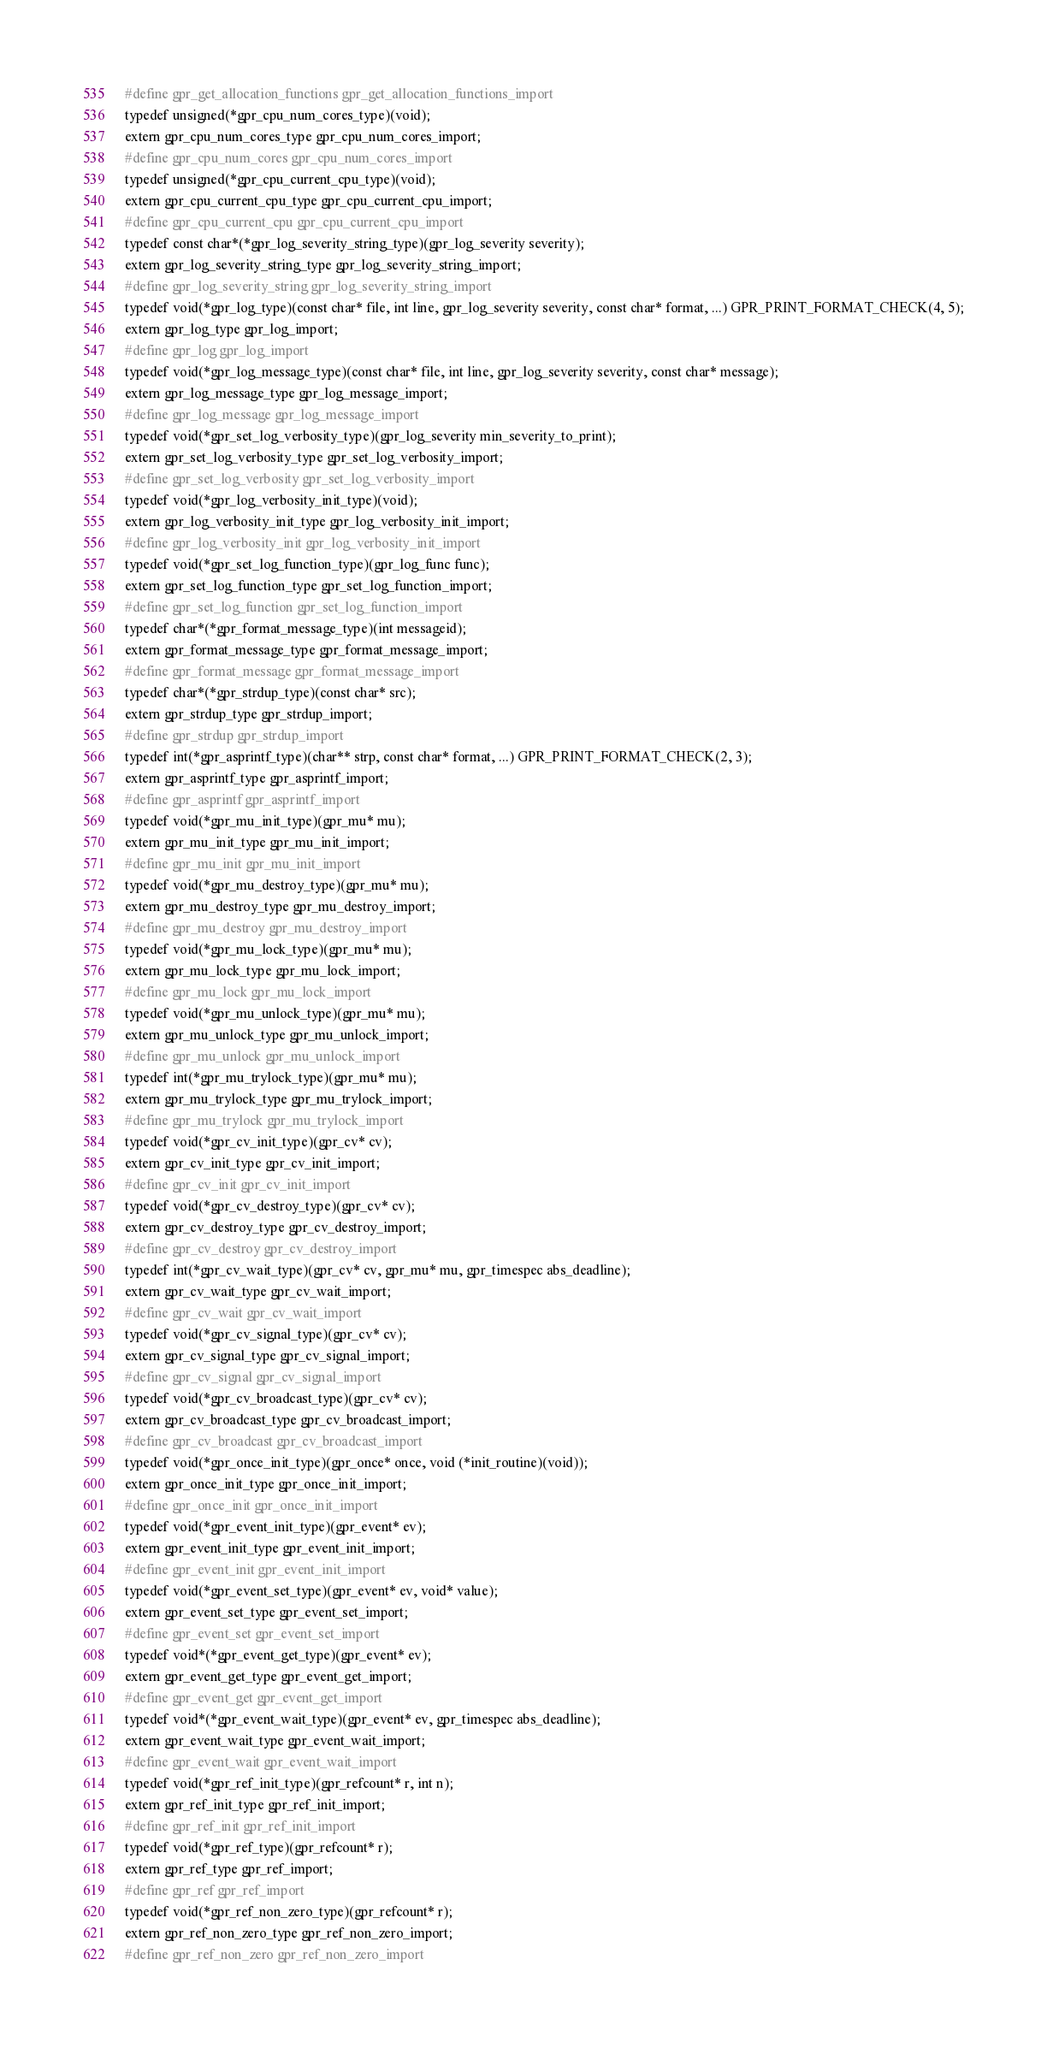<code> <loc_0><loc_0><loc_500><loc_500><_C_>#define gpr_get_allocation_functions gpr_get_allocation_functions_import
typedef unsigned(*gpr_cpu_num_cores_type)(void);
extern gpr_cpu_num_cores_type gpr_cpu_num_cores_import;
#define gpr_cpu_num_cores gpr_cpu_num_cores_import
typedef unsigned(*gpr_cpu_current_cpu_type)(void);
extern gpr_cpu_current_cpu_type gpr_cpu_current_cpu_import;
#define gpr_cpu_current_cpu gpr_cpu_current_cpu_import
typedef const char*(*gpr_log_severity_string_type)(gpr_log_severity severity);
extern gpr_log_severity_string_type gpr_log_severity_string_import;
#define gpr_log_severity_string gpr_log_severity_string_import
typedef void(*gpr_log_type)(const char* file, int line, gpr_log_severity severity, const char* format, ...) GPR_PRINT_FORMAT_CHECK(4, 5);
extern gpr_log_type gpr_log_import;
#define gpr_log gpr_log_import
typedef void(*gpr_log_message_type)(const char* file, int line, gpr_log_severity severity, const char* message);
extern gpr_log_message_type gpr_log_message_import;
#define gpr_log_message gpr_log_message_import
typedef void(*gpr_set_log_verbosity_type)(gpr_log_severity min_severity_to_print);
extern gpr_set_log_verbosity_type gpr_set_log_verbosity_import;
#define gpr_set_log_verbosity gpr_set_log_verbosity_import
typedef void(*gpr_log_verbosity_init_type)(void);
extern gpr_log_verbosity_init_type gpr_log_verbosity_init_import;
#define gpr_log_verbosity_init gpr_log_verbosity_init_import
typedef void(*gpr_set_log_function_type)(gpr_log_func func);
extern gpr_set_log_function_type gpr_set_log_function_import;
#define gpr_set_log_function gpr_set_log_function_import
typedef char*(*gpr_format_message_type)(int messageid);
extern gpr_format_message_type gpr_format_message_import;
#define gpr_format_message gpr_format_message_import
typedef char*(*gpr_strdup_type)(const char* src);
extern gpr_strdup_type gpr_strdup_import;
#define gpr_strdup gpr_strdup_import
typedef int(*gpr_asprintf_type)(char** strp, const char* format, ...) GPR_PRINT_FORMAT_CHECK(2, 3);
extern gpr_asprintf_type gpr_asprintf_import;
#define gpr_asprintf gpr_asprintf_import
typedef void(*gpr_mu_init_type)(gpr_mu* mu);
extern gpr_mu_init_type gpr_mu_init_import;
#define gpr_mu_init gpr_mu_init_import
typedef void(*gpr_mu_destroy_type)(gpr_mu* mu);
extern gpr_mu_destroy_type gpr_mu_destroy_import;
#define gpr_mu_destroy gpr_mu_destroy_import
typedef void(*gpr_mu_lock_type)(gpr_mu* mu);
extern gpr_mu_lock_type gpr_mu_lock_import;
#define gpr_mu_lock gpr_mu_lock_import
typedef void(*gpr_mu_unlock_type)(gpr_mu* mu);
extern gpr_mu_unlock_type gpr_mu_unlock_import;
#define gpr_mu_unlock gpr_mu_unlock_import
typedef int(*gpr_mu_trylock_type)(gpr_mu* mu);
extern gpr_mu_trylock_type gpr_mu_trylock_import;
#define gpr_mu_trylock gpr_mu_trylock_import
typedef void(*gpr_cv_init_type)(gpr_cv* cv);
extern gpr_cv_init_type gpr_cv_init_import;
#define gpr_cv_init gpr_cv_init_import
typedef void(*gpr_cv_destroy_type)(gpr_cv* cv);
extern gpr_cv_destroy_type gpr_cv_destroy_import;
#define gpr_cv_destroy gpr_cv_destroy_import
typedef int(*gpr_cv_wait_type)(gpr_cv* cv, gpr_mu* mu, gpr_timespec abs_deadline);
extern gpr_cv_wait_type gpr_cv_wait_import;
#define gpr_cv_wait gpr_cv_wait_import
typedef void(*gpr_cv_signal_type)(gpr_cv* cv);
extern gpr_cv_signal_type gpr_cv_signal_import;
#define gpr_cv_signal gpr_cv_signal_import
typedef void(*gpr_cv_broadcast_type)(gpr_cv* cv);
extern gpr_cv_broadcast_type gpr_cv_broadcast_import;
#define gpr_cv_broadcast gpr_cv_broadcast_import
typedef void(*gpr_once_init_type)(gpr_once* once, void (*init_routine)(void));
extern gpr_once_init_type gpr_once_init_import;
#define gpr_once_init gpr_once_init_import
typedef void(*gpr_event_init_type)(gpr_event* ev);
extern gpr_event_init_type gpr_event_init_import;
#define gpr_event_init gpr_event_init_import
typedef void(*gpr_event_set_type)(gpr_event* ev, void* value);
extern gpr_event_set_type gpr_event_set_import;
#define gpr_event_set gpr_event_set_import
typedef void*(*gpr_event_get_type)(gpr_event* ev);
extern gpr_event_get_type gpr_event_get_import;
#define gpr_event_get gpr_event_get_import
typedef void*(*gpr_event_wait_type)(gpr_event* ev, gpr_timespec abs_deadline);
extern gpr_event_wait_type gpr_event_wait_import;
#define gpr_event_wait gpr_event_wait_import
typedef void(*gpr_ref_init_type)(gpr_refcount* r, int n);
extern gpr_ref_init_type gpr_ref_init_import;
#define gpr_ref_init gpr_ref_init_import
typedef void(*gpr_ref_type)(gpr_refcount* r);
extern gpr_ref_type gpr_ref_import;
#define gpr_ref gpr_ref_import
typedef void(*gpr_ref_non_zero_type)(gpr_refcount* r);
extern gpr_ref_non_zero_type gpr_ref_non_zero_import;
#define gpr_ref_non_zero gpr_ref_non_zero_import</code> 